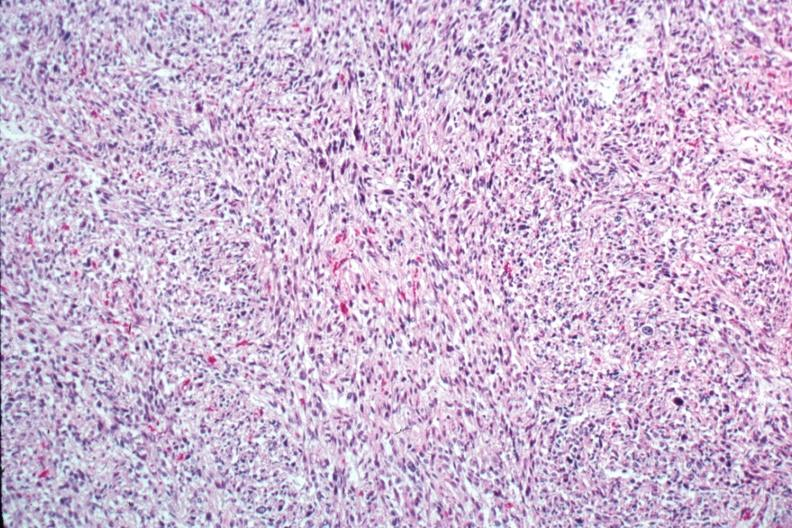s this great toe present?
Answer the question using a single word or phrase. No 